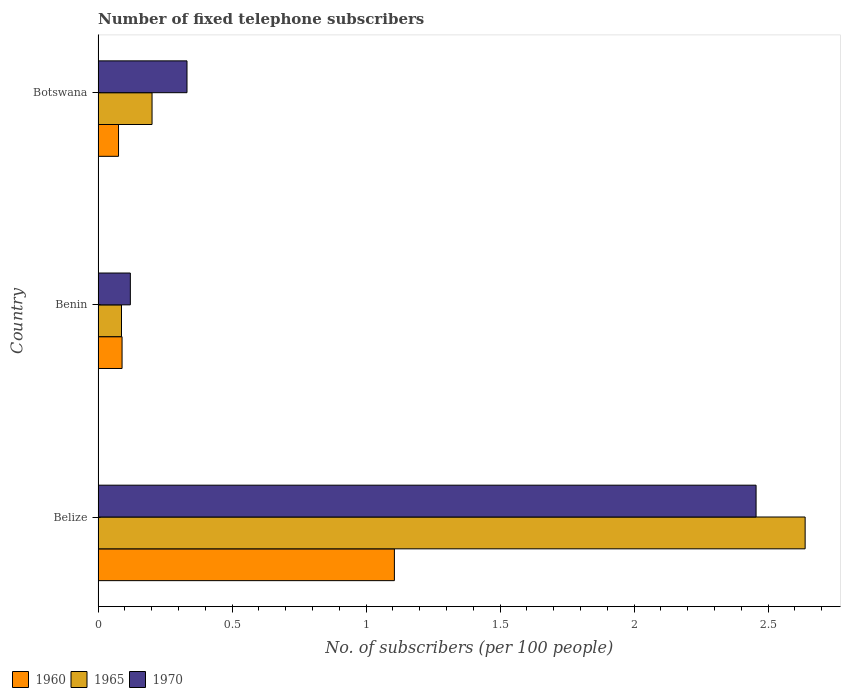How many different coloured bars are there?
Provide a short and direct response. 3. What is the label of the 1st group of bars from the top?
Offer a terse response. Botswana. What is the number of fixed telephone subscribers in 1970 in Botswana?
Offer a very short reply. 0.33. Across all countries, what is the maximum number of fixed telephone subscribers in 1960?
Give a very brief answer. 1.11. Across all countries, what is the minimum number of fixed telephone subscribers in 1965?
Keep it short and to the point. 0.09. In which country was the number of fixed telephone subscribers in 1960 maximum?
Provide a short and direct response. Belize. In which country was the number of fixed telephone subscribers in 1960 minimum?
Your response must be concise. Botswana. What is the total number of fixed telephone subscribers in 1965 in the graph?
Make the answer very short. 2.93. What is the difference between the number of fixed telephone subscribers in 1960 in Benin and that in Botswana?
Keep it short and to the point. 0.01. What is the difference between the number of fixed telephone subscribers in 1965 in Belize and the number of fixed telephone subscribers in 1970 in Botswana?
Make the answer very short. 2.31. What is the average number of fixed telephone subscribers in 1970 per country?
Your response must be concise. 0.97. What is the difference between the number of fixed telephone subscribers in 1970 and number of fixed telephone subscribers in 1965 in Belize?
Your answer should be compact. -0.18. What is the ratio of the number of fixed telephone subscribers in 1970 in Benin to that in Botswana?
Ensure brevity in your answer.  0.36. What is the difference between the highest and the second highest number of fixed telephone subscribers in 1970?
Offer a very short reply. 2.12. What is the difference between the highest and the lowest number of fixed telephone subscribers in 1970?
Your response must be concise. 2.34. Is the sum of the number of fixed telephone subscribers in 1970 in Benin and Botswana greater than the maximum number of fixed telephone subscribers in 1965 across all countries?
Offer a terse response. No. What does the 2nd bar from the top in Belize represents?
Your response must be concise. 1965. Is it the case that in every country, the sum of the number of fixed telephone subscribers in 1965 and number of fixed telephone subscribers in 1960 is greater than the number of fixed telephone subscribers in 1970?
Make the answer very short. No. Are all the bars in the graph horizontal?
Your response must be concise. Yes. How many countries are there in the graph?
Provide a short and direct response. 3. Does the graph contain grids?
Your response must be concise. No. What is the title of the graph?
Provide a succinct answer. Number of fixed telephone subscribers. What is the label or title of the X-axis?
Your answer should be compact. No. of subscribers (per 100 people). What is the label or title of the Y-axis?
Keep it short and to the point. Country. What is the No. of subscribers (per 100 people) of 1960 in Belize?
Your response must be concise. 1.11. What is the No. of subscribers (per 100 people) in 1965 in Belize?
Ensure brevity in your answer.  2.64. What is the No. of subscribers (per 100 people) in 1970 in Belize?
Your response must be concise. 2.46. What is the No. of subscribers (per 100 people) in 1960 in Benin?
Keep it short and to the point. 0.09. What is the No. of subscribers (per 100 people) in 1965 in Benin?
Give a very brief answer. 0.09. What is the No. of subscribers (per 100 people) of 1970 in Benin?
Your answer should be very brief. 0.12. What is the No. of subscribers (per 100 people) in 1960 in Botswana?
Ensure brevity in your answer.  0.08. What is the No. of subscribers (per 100 people) in 1965 in Botswana?
Keep it short and to the point. 0.2. What is the No. of subscribers (per 100 people) of 1970 in Botswana?
Your answer should be very brief. 0.33. Across all countries, what is the maximum No. of subscribers (per 100 people) in 1960?
Your answer should be very brief. 1.11. Across all countries, what is the maximum No. of subscribers (per 100 people) in 1965?
Offer a very short reply. 2.64. Across all countries, what is the maximum No. of subscribers (per 100 people) of 1970?
Your answer should be very brief. 2.46. Across all countries, what is the minimum No. of subscribers (per 100 people) of 1960?
Your answer should be very brief. 0.08. Across all countries, what is the minimum No. of subscribers (per 100 people) of 1965?
Ensure brevity in your answer.  0.09. Across all countries, what is the minimum No. of subscribers (per 100 people) in 1970?
Provide a short and direct response. 0.12. What is the total No. of subscribers (per 100 people) of 1960 in the graph?
Ensure brevity in your answer.  1.27. What is the total No. of subscribers (per 100 people) of 1965 in the graph?
Give a very brief answer. 2.93. What is the total No. of subscribers (per 100 people) in 1970 in the graph?
Your answer should be very brief. 2.91. What is the difference between the No. of subscribers (per 100 people) of 1960 in Belize and that in Benin?
Your answer should be very brief. 1.02. What is the difference between the No. of subscribers (per 100 people) of 1965 in Belize and that in Benin?
Your answer should be very brief. 2.55. What is the difference between the No. of subscribers (per 100 people) in 1970 in Belize and that in Benin?
Provide a short and direct response. 2.33. What is the difference between the No. of subscribers (per 100 people) in 1960 in Belize and that in Botswana?
Give a very brief answer. 1.03. What is the difference between the No. of subscribers (per 100 people) of 1965 in Belize and that in Botswana?
Provide a succinct answer. 2.44. What is the difference between the No. of subscribers (per 100 people) of 1970 in Belize and that in Botswana?
Provide a short and direct response. 2.12. What is the difference between the No. of subscribers (per 100 people) in 1960 in Benin and that in Botswana?
Ensure brevity in your answer.  0.01. What is the difference between the No. of subscribers (per 100 people) in 1965 in Benin and that in Botswana?
Your answer should be compact. -0.11. What is the difference between the No. of subscribers (per 100 people) in 1970 in Benin and that in Botswana?
Make the answer very short. -0.21. What is the difference between the No. of subscribers (per 100 people) of 1960 in Belize and the No. of subscribers (per 100 people) of 1965 in Benin?
Offer a terse response. 1.02. What is the difference between the No. of subscribers (per 100 people) in 1960 in Belize and the No. of subscribers (per 100 people) in 1970 in Benin?
Give a very brief answer. 0.99. What is the difference between the No. of subscribers (per 100 people) in 1965 in Belize and the No. of subscribers (per 100 people) in 1970 in Benin?
Provide a short and direct response. 2.52. What is the difference between the No. of subscribers (per 100 people) of 1960 in Belize and the No. of subscribers (per 100 people) of 1965 in Botswana?
Provide a succinct answer. 0.9. What is the difference between the No. of subscribers (per 100 people) in 1960 in Belize and the No. of subscribers (per 100 people) in 1970 in Botswana?
Ensure brevity in your answer.  0.77. What is the difference between the No. of subscribers (per 100 people) in 1965 in Belize and the No. of subscribers (per 100 people) in 1970 in Botswana?
Your answer should be very brief. 2.31. What is the difference between the No. of subscribers (per 100 people) of 1960 in Benin and the No. of subscribers (per 100 people) of 1965 in Botswana?
Provide a succinct answer. -0.11. What is the difference between the No. of subscribers (per 100 people) in 1960 in Benin and the No. of subscribers (per 100 people) in 1970 in Botswana?
Offer a very short reply. -0.24. What is the difference between the No. of subscribers (per 100 people) in 1965 in Benin and the No. of subscribers (per 100 people) in 1970 in Botswana?
Provide a short and direct response. -0.24. What is the average No. of subscribers (per 100 people) in 1960 per country?
Keep it short and to the point. 0.42. What is the average No. of subscribers (per 100 people) in 1965 per country?
Offer a terse response. 0.98. What is the average No. of subscribers (per 100 people) of 1970 per country?
Your response must be concise. 0.97. What is the difference between the No. of subscribers (per 100 people) in 1960 and No. of subscribers (per 100 people) in 1965 in Belize?
Your answer should be very brief. -1.53. What is the difference between the No. of subscribers (per 100 people) of 1960 and No. of subscribers (per 100 people) of 1970 in Belize?
Your response must be concise. -1.35. What is the difference between the No. of subscribers (per 100 people) of 1965 and No. of subscribers (per 100 people) of 1970 in Belize?
Your answer should be compact. 0.18. What is the difference between the No. of subscribers (per 100 people) of 1960 and No. of subscribers (per 100 people) of 1965 in Benin?
Offer a terse response. 0. What is the difference between the No. of subscribers (per 100 people) of 1960 and No. of subscribers (per 100 people) of 1970 in Benin?
Provide a succinct answer. -0.03. What is the difference between the No. of subscribers (per 100 people) of 1965 and No. of subscribers (per 100 people) of 1970 in Benin?
Your answer should be compact. -0.03. What is the difference between the No. of subscribers (per 100 people) in 1960 and No. of subscribers (per 100 people) in 1965 in Botswana?
Your answer should be compact. -0.13. What is the difference between the No. of subscribers (per 100 people) in 1960 and No. of subscribers (per 100 people) in 1970 in Botswana?
Keep it short and to the point. -0.26. What is the difference between the No. of subscribers (per 100 people) of 1965 and No. of subscribers (per 100 people) of 1970 in Botswana?
Keep it short and to the point. -0.13. What is the ratio of the No. of subscribers (per 100 people) in 1960 in Belize to that in Benin?
Your answer should be compact. 12.36. What is the ratio of the No. of subscribers (per 100 people) of 1965 in Belize to that in Benin?
Ensure brevity in your answer.  30.2. What is the ratio of the No. of subscribers (per 100 people) of 1970 in Belize to that in Benin?
Keep it short and to the point. 20.4. What is the ratio of the No. of subscribers (per 100 people) in 1960 in Belize to that in Botswana?
Offer a very short reply. 14.49. What is the ratio of the No. of subscribers (per 100 people) of 1965 in Belize to that in Botswana?
Your answer should be compact. 13.1. What is the ratio of the No. of subscribers (per 100 people) of 1970 in Belize to that in Botswana?
Your answer should be very brief. 7.4. What is the ratio of the No. of subscribers (per 100 people) of 1960 in Benin to that in Botswana?
Make the answer very short. 1.17. What is the ratio of the No. of subscribers (per 100 people) of 1965 in Benin to that in Botswana?
Your answer should be very brief. 0.43. What is the ratio of the No. of subscribers (per 100 people) of 1970 in Benin to that in Botswana?
Offer a terse response. 0.36. What is the difference between the highest and the second highest No. of subscribers (per 100 people) of 1960?
Give a very brief answer. 1.02. What is the difference between the highest and the second highest No. of subscribers (per 100 people) in 1965?
Your answer should be very brief. 2.44. What is the difference between the highest and the second highest No. of subscribers (per 100 people) in 1970?
Keep it short and to the point. 2.12. What is the difference between the highest and the lowest No. of subscribers (per 100 people) in 1960?
Keep it short and to the point. 1.03. What is the difference between the highest and the lowest No. of subscribers (per 100 people) in 1965?
Offer a very short reply. 2.55. What is the difference between the highest and the lowest No. of subscribers (per 100 people) in 1970?
Give a very brief answer. 2.33. 